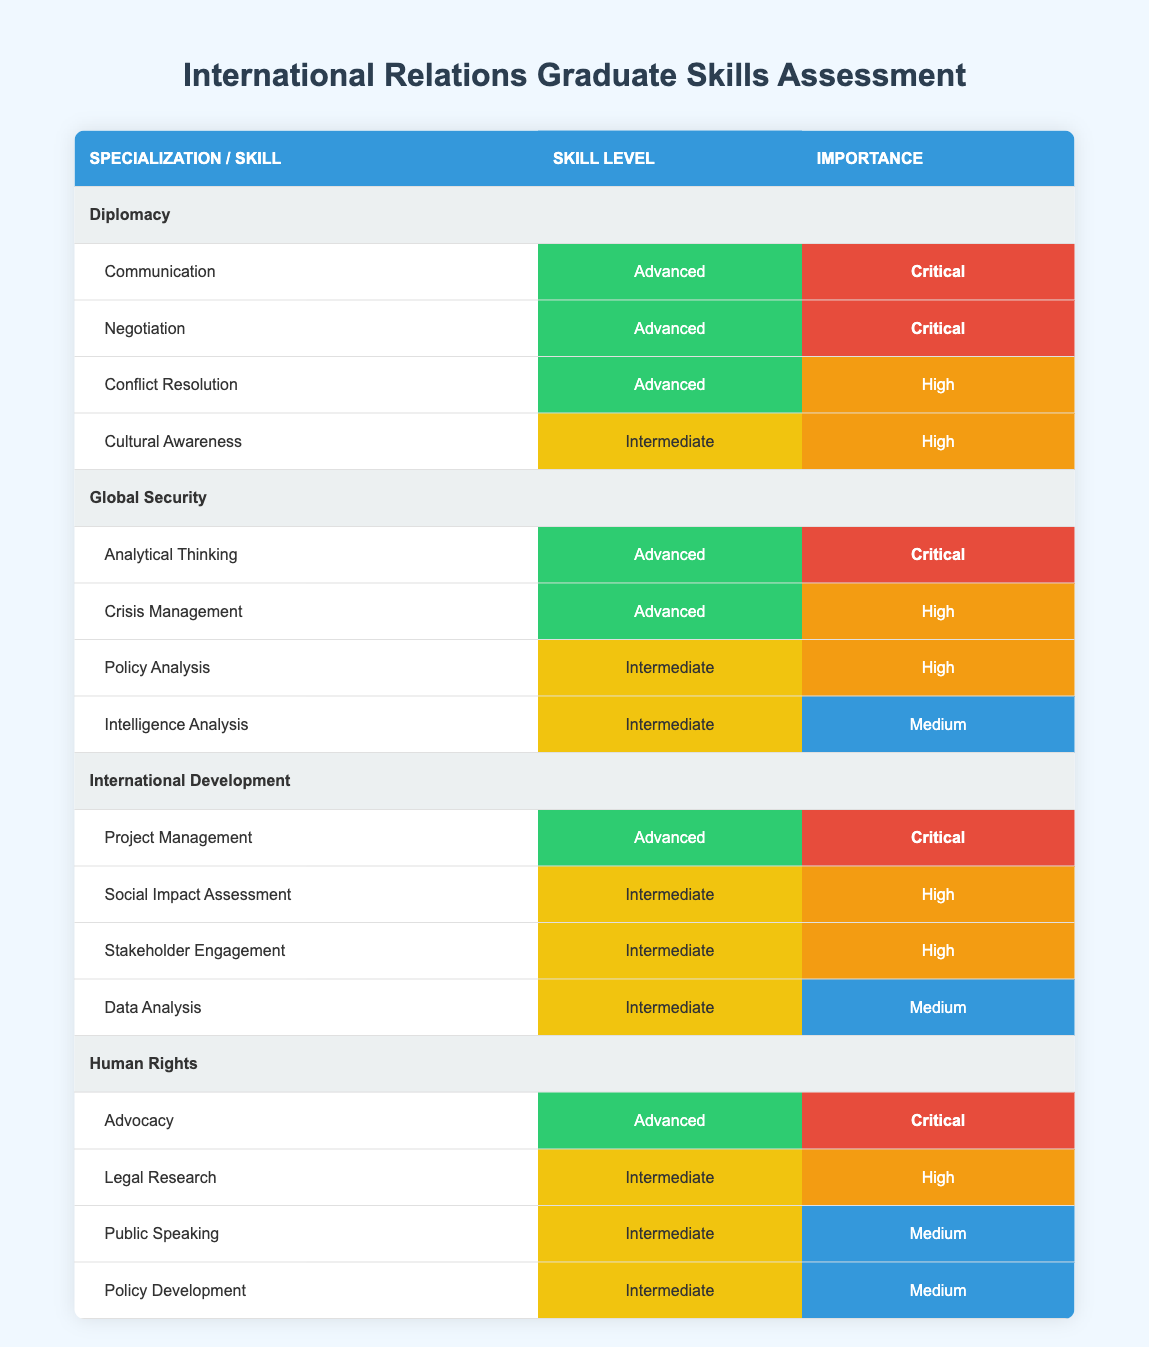What is the skill level of Advocacy in Human Rights specialization? The table shows that the skill level for Advocacy is categorized as "Advanced."
Answer: Advanced Which skills listed under Diplomacy have a critical importance rating? The table indicates that in the Diplomacy specialization, both Communication and Negotiation have a critical importance rating.
Answer: Communication and Negotiation How many skills in Global Security have an advanced skill level? Within the Global Security specialization, there are two skills listed with an advanced skill level: Analytical Thinking and Crisis Management.
Answer: 2 Is Conflict Resolution rated as a critical importance skill in Diplomacy? According to the table, Conflict Resolution is rated as "High" in importance, not critical. Therefore, the answer is no.
Answer: No What is the average importance level of skills in International Development? The importance ratings for International Development skills are: Critical (1), High (2), and Medium (1). The total ratings count is 4 (1+2+1). "Critical" counts as 3, "High" counts as 2, and "Medium" counts as 1. Hence, the total importance score is 3 + 2*2 + 1 = 8. Dividing by the number of skills (4), the average becomes 8/4 = 2.
Answer: 2 Which specialization has the highest number of skills rated at an intermediate skill level? Analyzing the table, International Development lists 3 skills with an intermediate skill level, which is more than any other specialization. The breakdown is as follows: Diplomacy (1), Global Security (2), Human Rights (3), and International Development (3). Therefore, there is a tie between Global Security and International Development for the highest number.
Answer: International Development and Global Security What is the importance of Data Analysis in International Development? In International Development, the importance of Data Analysis is rated as "Medium," as per the table.
Answer: Medium Does Global Security have a skill labeled as "Intelligence Analysis"? The table confirms that Global Security includes a skill called "Intelligence Analysis." This is a straightforward retrieval from the table.
Answer: Yes What is the total number of skills that are rated as advanced across all specializations? Summing the advanced skills: Diplomacy (3), Global Security (2), International Development (1), Human Rights (1). This totals 7 advanced skills across all specializations (3 + 2 + 1 + 1 = 7).
Answer: 7 